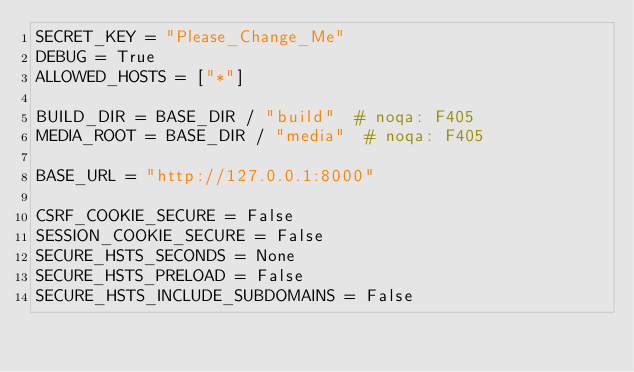Convert code to text. <code><loc_0><loc_0><loc_500><loc_500><_Python_>SECRET_KEY = "Please_Change_Me"
DEBUG = True
ALLOWED_HOSTS = ["*"]

BUILD_DIR = BASE_DIR / "build"  # noqa: F405
MEDIA_ROOT = BASE_DIR / "media"  # noqa: F405

BASE_URL = "http://127.0.0.1:8000"

CSRF_COOKIE_SECURE = False
SESSION_COOKIE_SECURE = False
SECURE_HSTS_SECONDS = None
SECURE_HSTS_PRELOAD = False
SECURE_HSTS_INCLUDE_SUBDOMAINS = False
</code> 